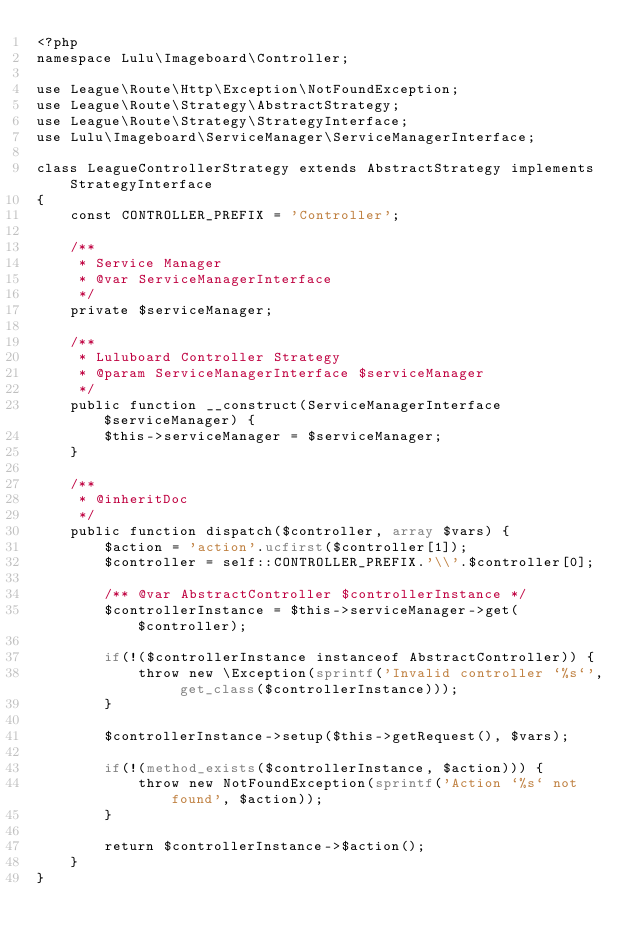<code> <loc_0><loc_0><loc_500><loc_500><_PHP_><?php
namespace Lulu\Imageboard\Controller;

use League\Route\Http\Exception\NotFoundException;
use League\Route\Strategy\AbstractStrategy;
use League\Route\Strategy\StrategyInterface;
use Lulu\Imageboard\ServiceManager\ServiceManagerInterface;

class LeagueControllerStrategy extends AbstractStrategy implements StrategyInterface
{
    const CONTROLLER_PREFIX = 'Controller';

    /**
     * Service Manager
     * @var ServiceManagerInterface
     */
    private $serviceManager;

    /**
     * Luluboard Controller Strategy
     * @param ServiceManagerInterface $serviceManager
     */
    public function __construct(ServiceManagerInterface $serviceManager) {
        $this->serviceManager = $serviceManager;
    }

    /**
     * @inheritDoc
     */
    public function dispatch($controller, array $vars) {
        $action = 'action'.ucfirst($controller[1]);
        $controller = self::CONTROLLER_PREFIX.'\\'.$controller[0];

        /** @var AbstractController $controllerInstance */
        $controllerInstance = $this->serviceManager->get($controller);

        if(!($controllerInstance instanceof AbstractController)) {
            throw new \Exception(sprintf('Invalid controller `%s`', get_class($controllerInstance)));
        }

        $controllerInstance->setup($this->getRequest(), $vars);

        if(!(method_exists($controllerInstance, $action))) {
            throw new NotFoundException(sprintf('Action `%s` not found', $action));
        }

        return $controllerInstance->$action();
    }
}</code> 